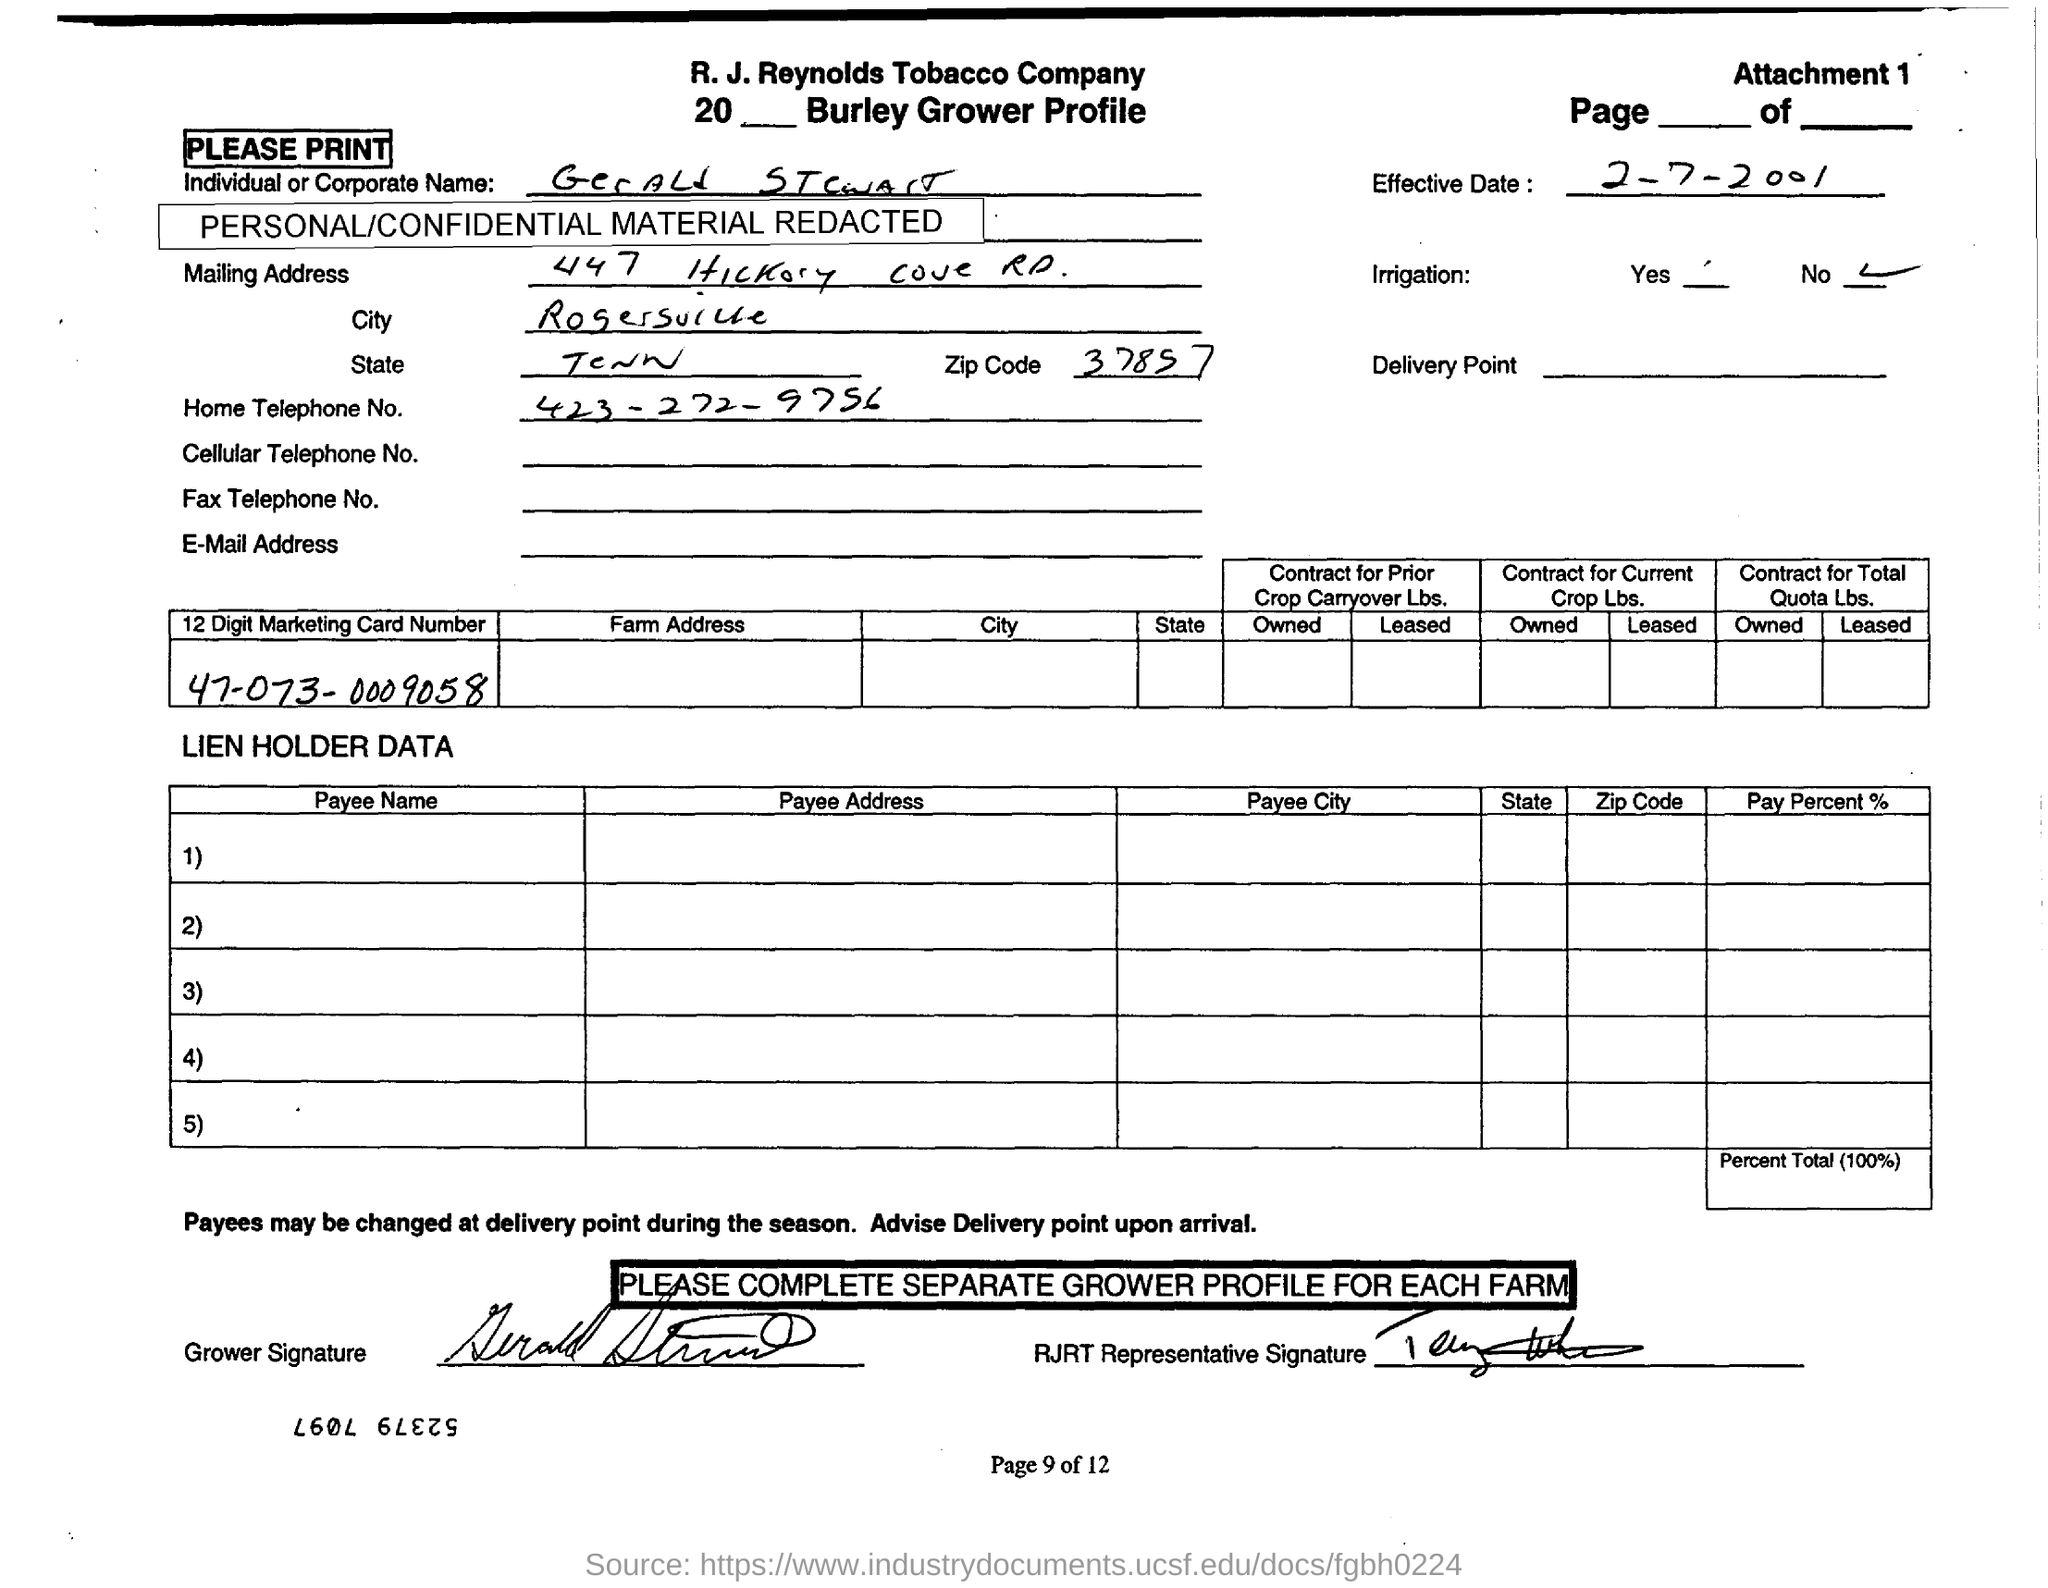What is the ZIP code mentioned in Mailing Address?
Give a very brief answer. 37857. What is the 'Effective Date' mentioned?
Provide a short and direct response. 2-7-2001. Whether 'Irrigation' is provided ?
Provide a succinct answer. No. What is the '12 Digit Marketing Card Number' written in first table?
Your response must be concise. 47-073-0009058. What is the page number of the document specified in the footer?
Offer a terse response. 9 of 12. Which company name is mentioned in the header ?
Give a very brief answer. R. J. Reynolds Tobacco Company. 